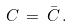<formula> <loc_0><loc_0><loc_500><loc_500>C \, = \, \bar { C } \, .</formula> 